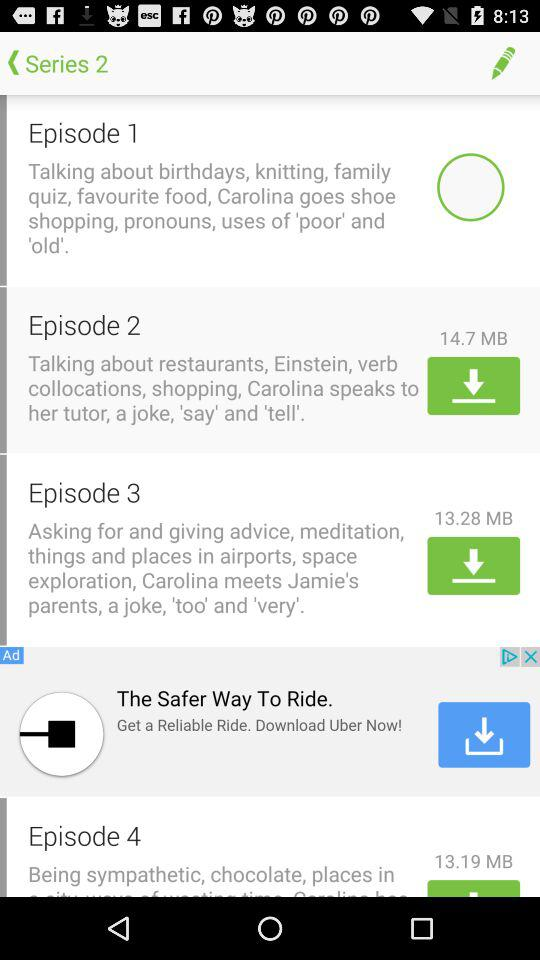Which series is this? This is series 2. 